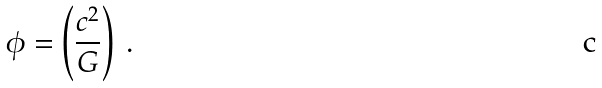Convert formula to latex. <formula><loc_0><loc_0><loc_500><loc_500>\phi = \left ( \frac { c ^ { 2 } } { G } \right ) \ .</formula> 